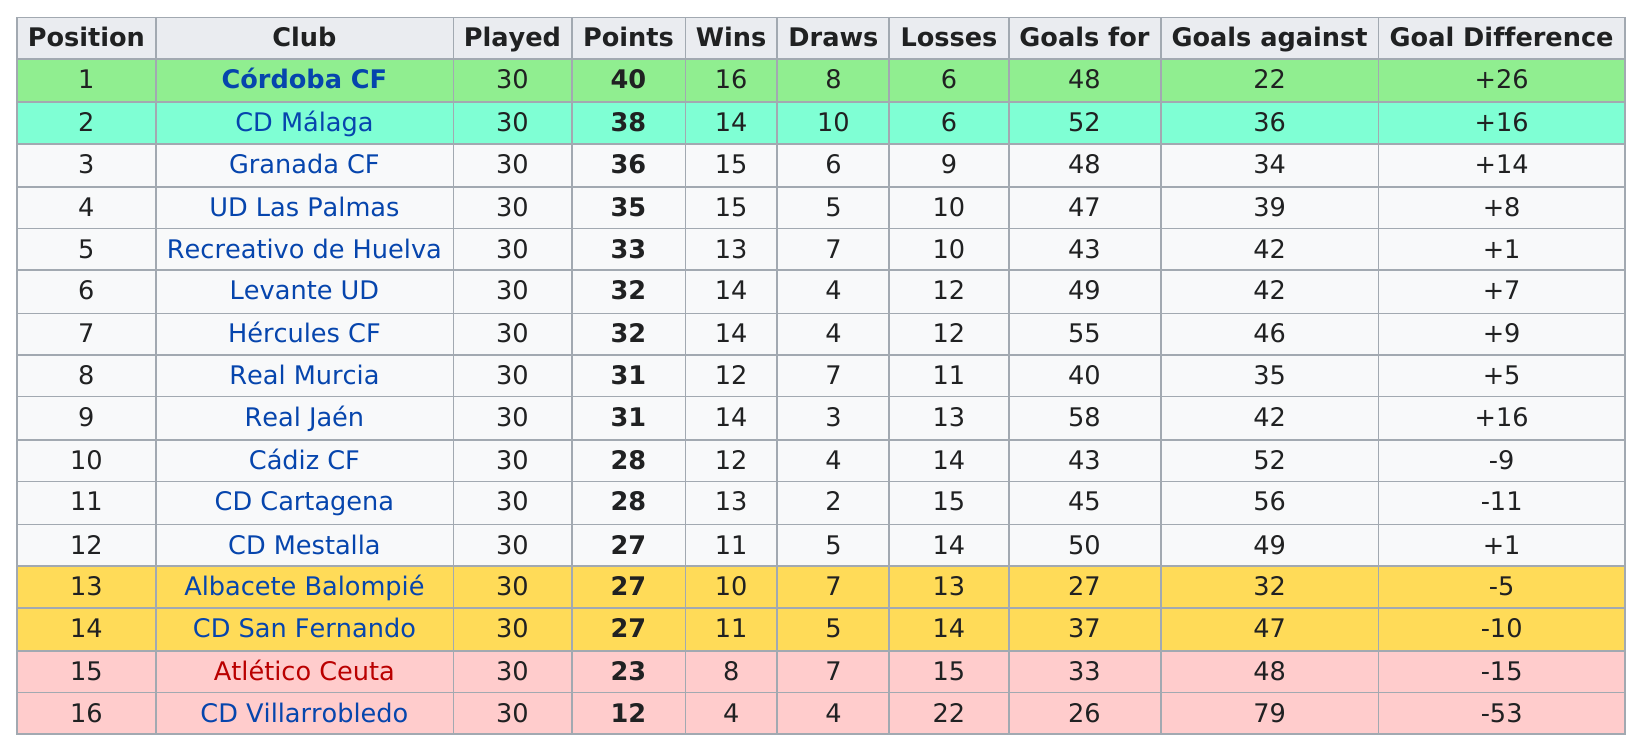Specify some key components in this picture. The club with only four wins was CD Villarrobledo. In the first game, the point difference between the first and last place teams was 28 points. After analyzing the data, it was found that there were no clubs that had no losses. The top team finished 28 points ahead of the bottom team, indicating a significant gap in the competitive standing between the two teams. CD Mestalla, a club with 27 points and a goal difference of +1, achieved a remarkable feat in the season. 